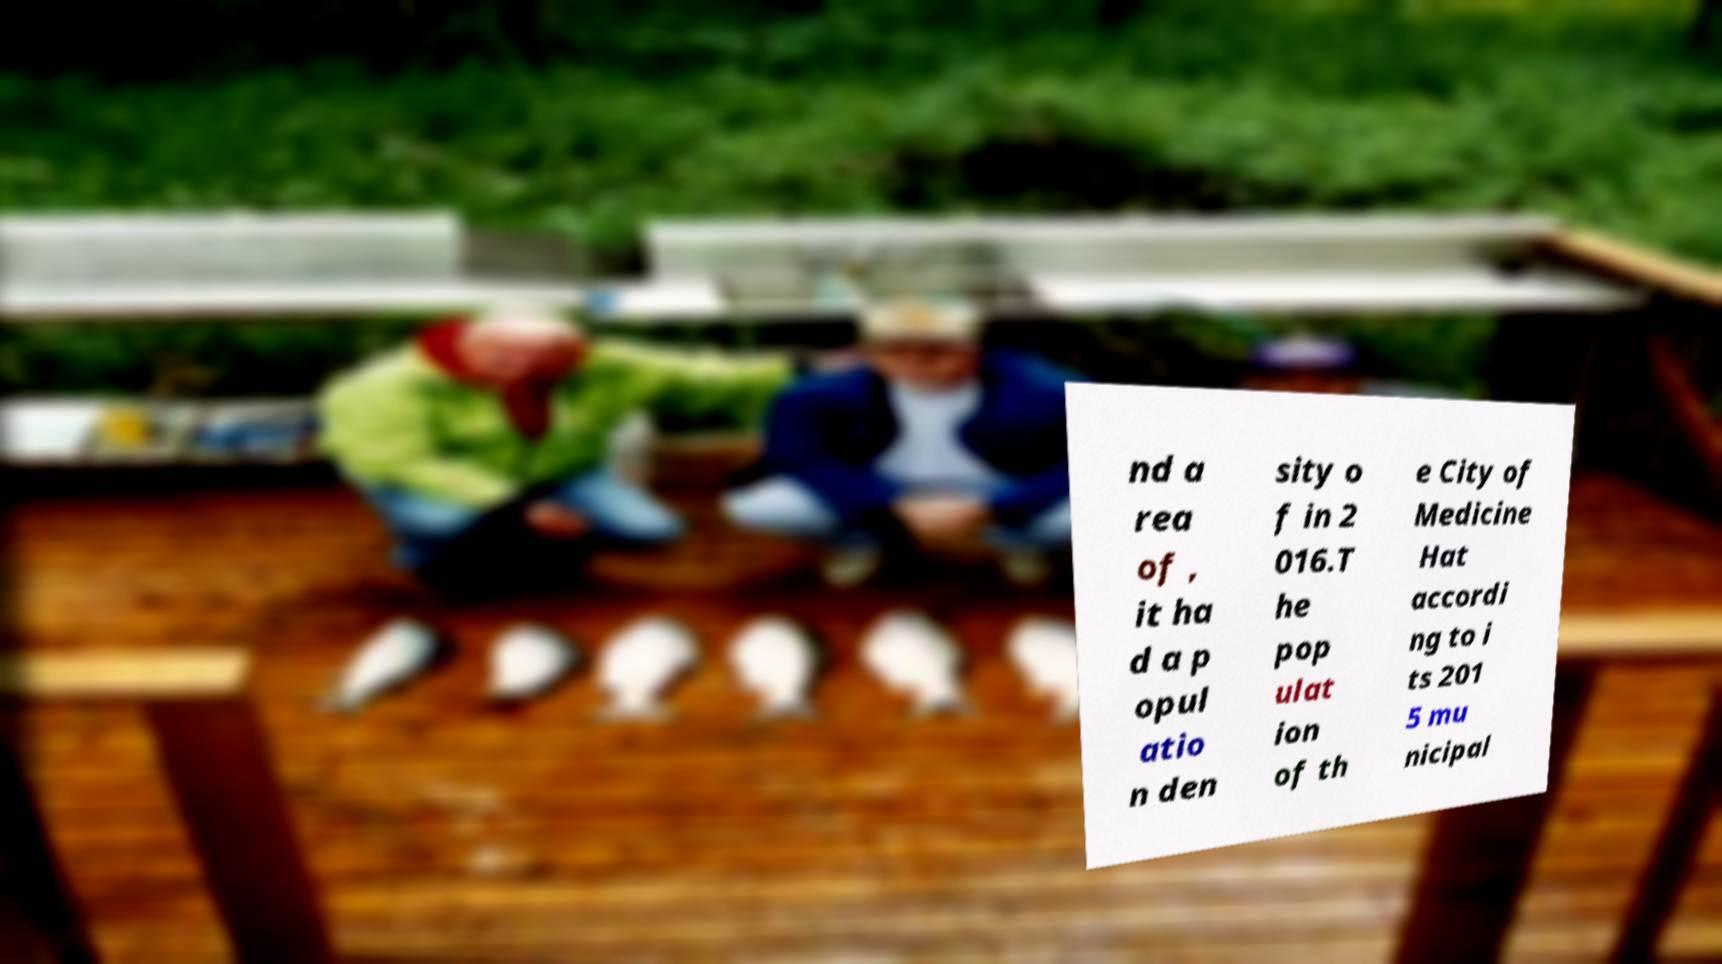There's text embedded in this image that I need extracted. Can you transcribe it verbatim? nd a rea of , it ha d a p opul atio n den sity o f in 2 016.T he pop ulat ion of th e City of Medicine Hat accordi ng to i ts 201 5 mu nicipal 